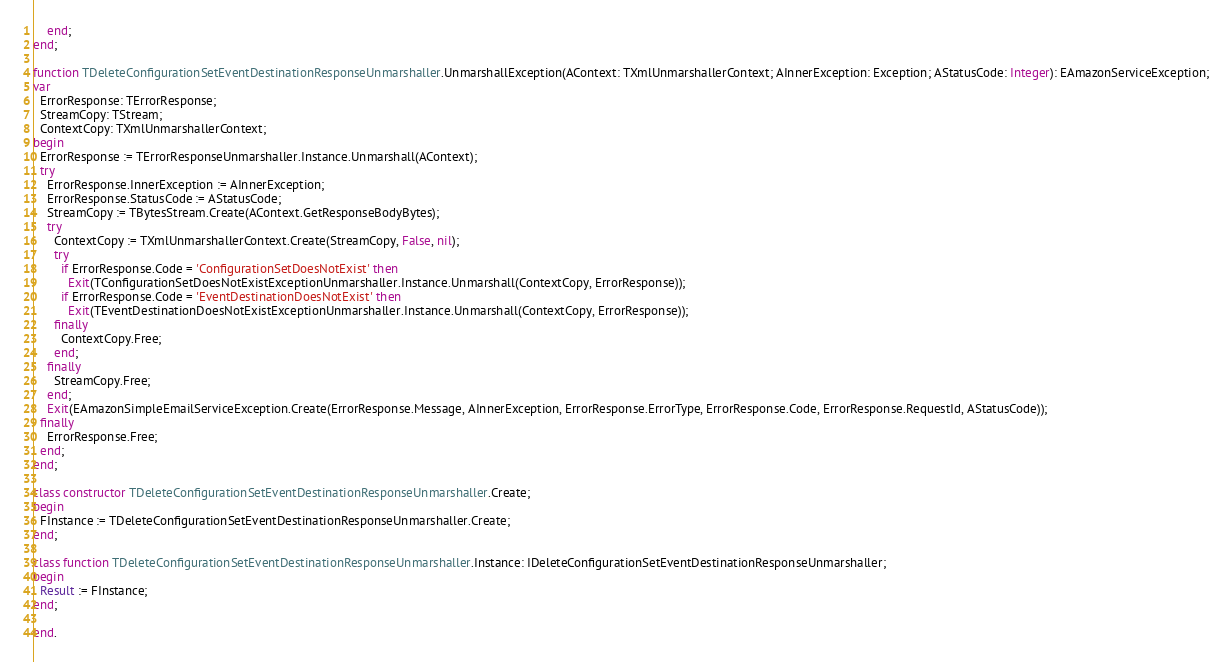<code> <loc_0><loc_0><loc_500><loc_500><_Pascal_>    end;
end;

function TDeleteConfigurationSetEventDestinationResponseUnmarshaller.UnmarshallException(AContext: TXmlUnmarshallerContext; AInnerException: Exception; AStatusCode: Integer): EAmazonServiceException;
var
  ErrorResponse: TErrorResponse;
  StreamCopy: TStream;
  ContextCopy: TXmlUnmarshallerContext;
begin
  ErrorResponse := TErrorResponseUnmarshaller.Instance.Unmarshall(AContext);
  try
    ErrorResponse.InnerException := AInnerException;
    ErrorResponse.StatusCode := AStatusCode;
    StreamCopy := TBytesStream.Create(AContext.GetResponseBodyBytes);
    try
      ContextCopy := TXmlUnmarshallerContext.Create(StreamCopy, False, nil);
      try
        if ErrorResponse.Code = 'ConfigurationSetDoesNotExist' then
          Exit(TConfigurationSetDoesNotExistExceptionUnmarshaller.Instance.Unmarshall(ContextCopy, ErrorResponse));
        if ErrorResponse.Code = 'EventDestinationDoesNotExist' then
          Exit(TEventDestinationDoesNotExistExceptionUnmarshaller.Instance.Unmarshall(ContextCopy, ErrorResponse));
      finally
        ContextCopy.Free;
      end;
    finally
      StreamCopy.Free;
    end;
    Exit(EAmazonSimpleEmailServiceException.Create(ErrorResponse.Message, AInnerException, ErrorResponse.ErrorType, ErrorResponse.Code, ErrorResponse.RequestId, AStatusCode));
  finally
    ErrorResponse.Free;
  end;
end;

class constructor TDeleteConfigurationSetEventDestinationResponseUnmarshaller.Create;
begin
  FInstance := TDeleteConfigurationSetEventDestinationResponseUnmarshaller.Create;
end;

class function TDeleteConfigurationSetEventDestinationResponseUnmarshaller.Instance: IDeleteConfigurationSetEventDestinationResponseUnmarshaller;
begin
  Result := FInstance;
end;

end.
</code> 